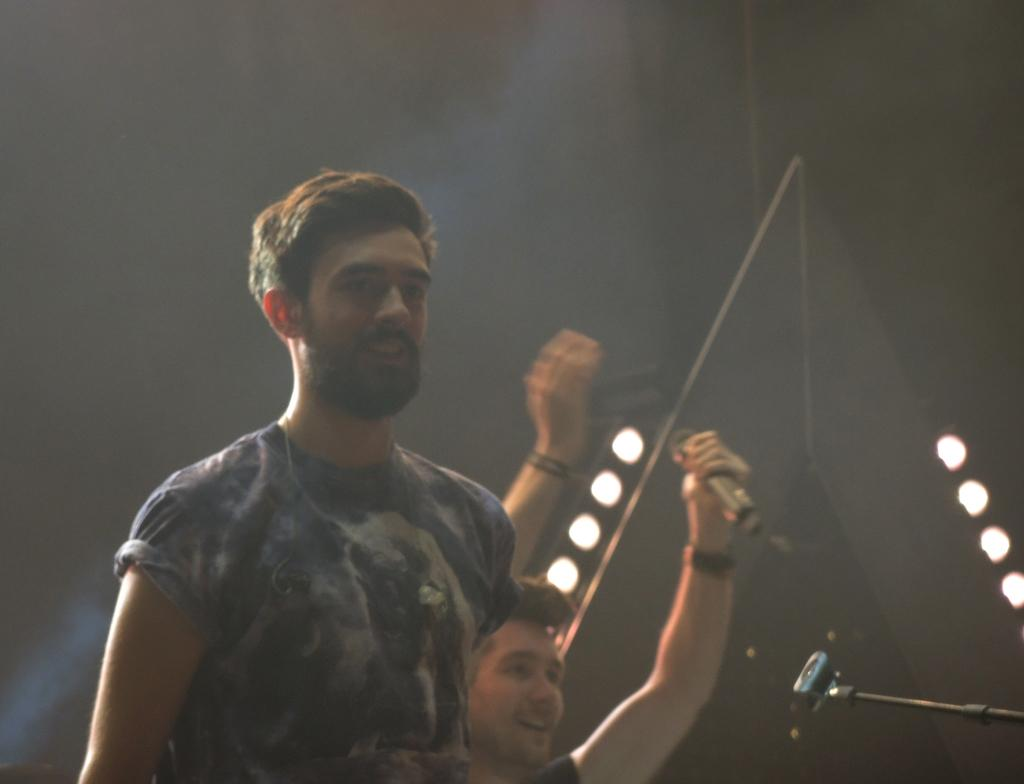What is the man in the image wearing? The man in the image is wearing a t-shirt. What is the man in the image doing? The man is laughing. What is the position of the man in the image? The man is standing. Can you describe the other person in the image? There is another man in the background of the image, and he is also laughing. What can be seen in the image related to lighting? There are lights visible in the image. What is present in the image that might indicate a performance or event? There is a microphone (mic) and a stand in the image. What else can be seen in the image? There are other materials present in the image. What type of calendar is hanging on the wall in the image? There is no calendar present in the image. Can you describe the cave where the man is standing in the image? There is no cave present in the image; it appears to be an indoor setting with lights and a stand. What kind of owl can be seen perched on the man's shoulder in the image? There is no owl present in the image. 